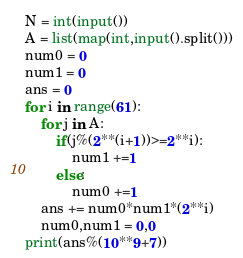<code> <loc_0><loc_0><loc_500><loc_500><_Python_>N = int(input())
A = list(map(int,input().split()))
num0 = 0
num1 = 0
ans = 0
for i in range(61):
    for j in A:
        if(j%(2**(i+1))>=2**i):
            num1 +=1
        else:
            num0 +=1
    ans += num0*num1*(2**i)
    num0,num1 = 0,0
print(ans%(10**9+7))</code> 